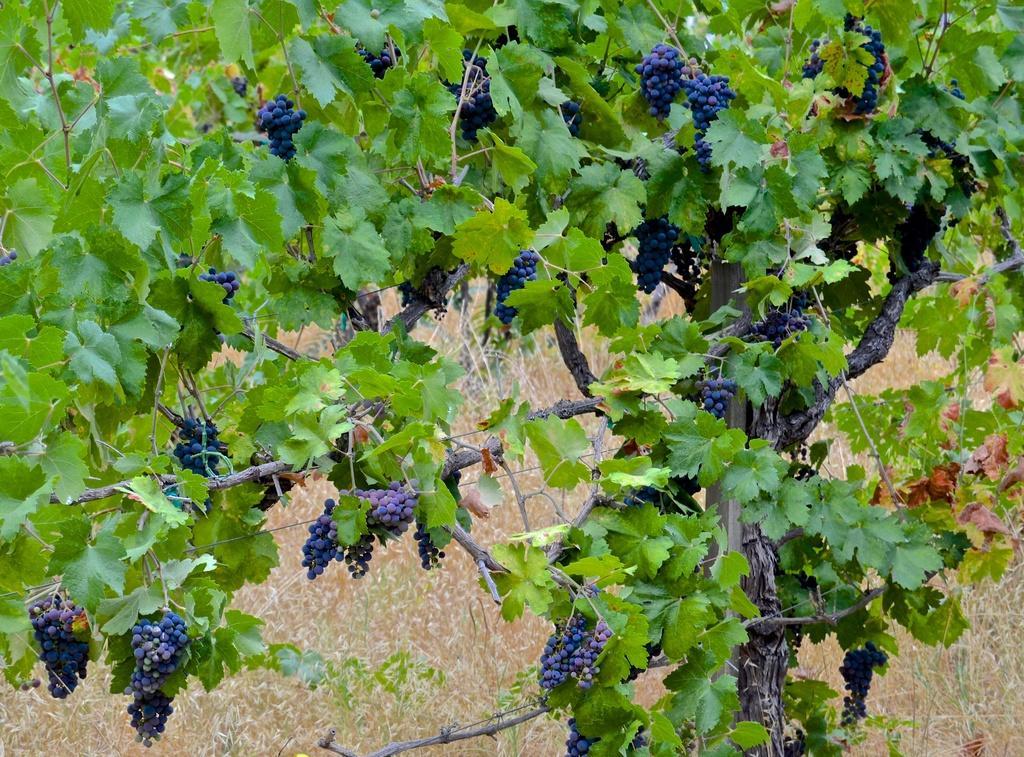Could you give a brief overview of what you see in this image? In this picture we can see grapes, leaves and in the background we can see grass. 